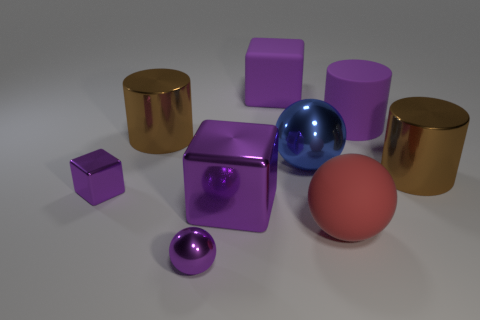Subtract all cylinders. How many objects are left? 6 Add 4 large red balls. How many large red balls are left? 5 Add 7 tiny purple blocks. How many tiny purple blocks exist? 8 Subtract 0 green cylinders. How many objects are left? 9 Subtract all tiny balls. Subtract all blocks. How many objects are left? 5 